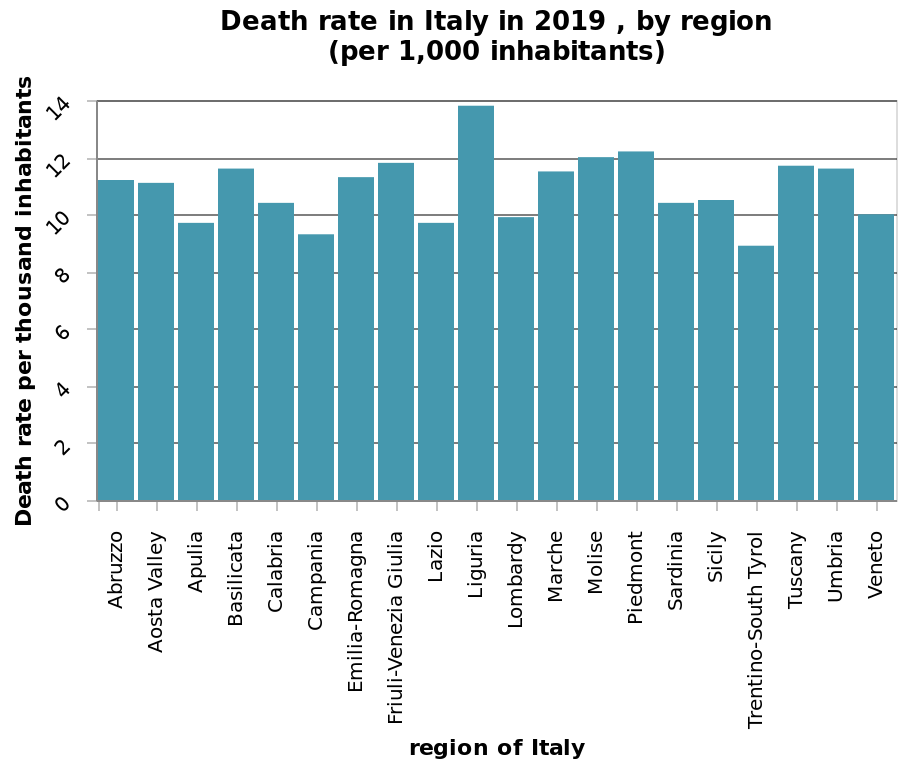<image>
How many regions of Italy are represented on the x-axis? The x-axis of the bar diagram represents multiple regions of Italy, but the description does not specify the exact number. What were the highest and lowest death rates in Italy in 2019? The highest death rate was recorded in Liguria, while the lowest death rate was observed in Trentino in Italy in 2019. 